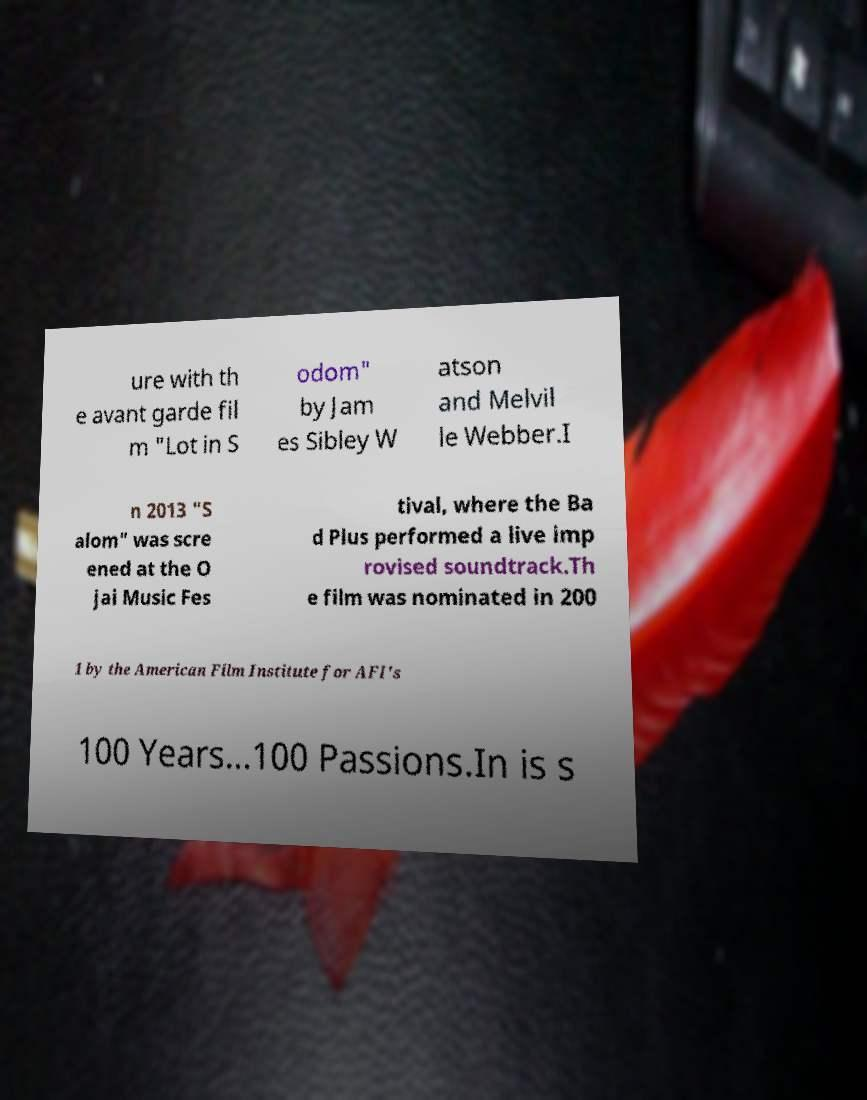Could you assist in decoding the text presented in this image and type it out clearly? ure with th e avant garde fil m "Lot in S odom" by Jam es Sibley W atson and Melvil le Webber.I n 2013 "S alom" was scre ened at the O jai Music Fes tival, where the Ba d Plus performed a live imp rovised soundtrack.Th e film was nominated in 200 1 by the American Film Institute for AFI's 100 Years...100 Passions.In is s 